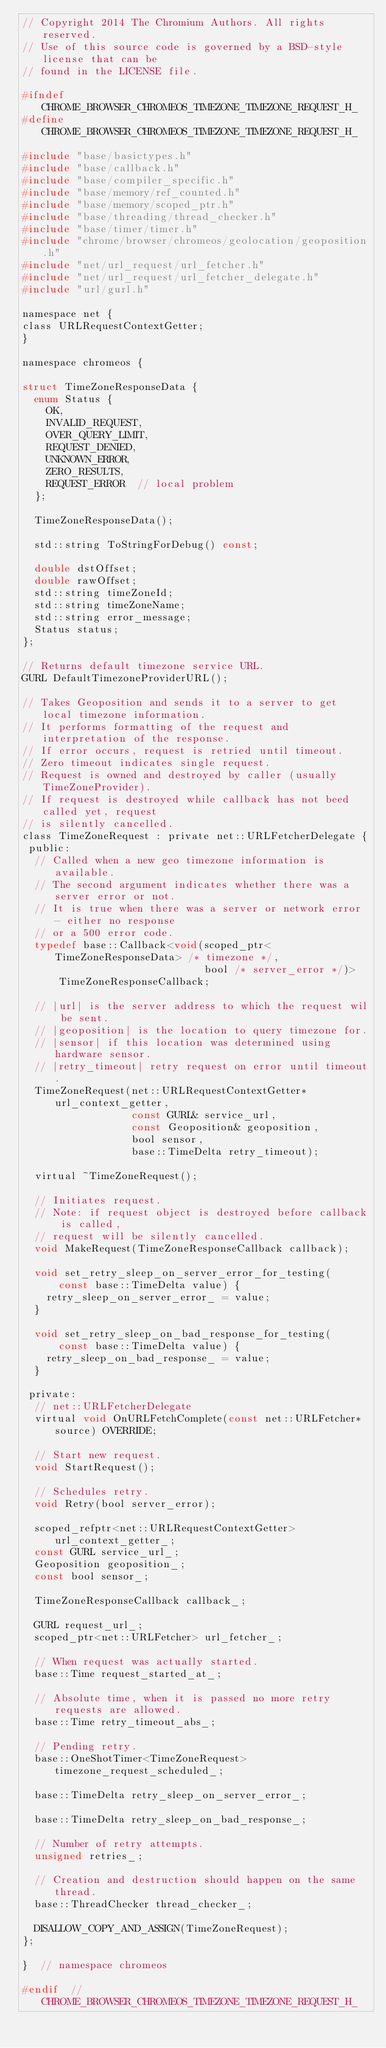<code> <loc_0><loc_0><loc_500><loc_500><_C_>// Copyright 2014 The Chromium Authors. All rights reserved.
// Use of this source code is governed by a BSD-style license that can be
// found in the LICENSE file.

#ifndef CHROME_BROWSER_CHROMEOS_TIMEZONE_TIMEZONE_REQUEST_H_
#define CHROME_BROWSER_CHROMEOS_TIMEZONE_TIMEZONE_REQUEST_H_

#include "base/basictypes.h"
#include "base/callback.h"
#include "base/compiler_specific.h"
#include "base/memory/ref_counted.h"
#include "base/memory/scoped_ptr.h"
#include "base/threading/thread_checker.h"
#include "base/timer/timer.h"
#include "chrome/browser/chromeos/geolocation/geoposition.h"
#include "net/url_request/url_fetcher.h"
#include "net/url_request/url_fetcher_delegate.h"
#include "url/gurl.h"

namespace net {
class URLRequestContextGetter;
}

namespace chromeos {

struct TimeZoneResponseData {
  enum Status {
    OK,
    INVALID_REQUEST,
    OVER_QUERY_LIMIT,
    REQUEST_DENIED,
    UNKNOWN_ERROR,
    ZERO_RESULTS,
    REQUEST_ERROR  // local problem
  };

  TimeZoneResponseData();

  std::string ToStringForDebug() const;

  double dstOffset;
  double rawOffset;
  std::string timeZoneId;
  std::string timeZoneName;
  std::string error_message;
  Status status;
};

// Returns default timezone service URL.
GURL DefaultTimezoneProviderURL();

// Takes Geoposition and sends it to a server to get local timezone information.
// It performs formatting of the request and interpretation of the response.
// If error occurs, request is retried until timeout.
// Zero timeout indicates single request.
// Request is owned and destroyed by caller (usually TimeZoneProvider).
// If request is destroyed while callback has not beed called yet, request
// is silently cancelled.
class TimeZoneRequest : private net::URLFetcherDelegate {
 public:
  // Called when a new geo timezone information is available.
  // The second argument indicates whether there was a server error or not.
  // It is true when there was a server or network error - either no response
  // or a 500 error code.
  typedef base::Callback<void(scoped_ptr<TimeZoneResponseData> /* timezone */,
                              bool /* server_error */)>
      TimeZoneResponseCallback;

  // |url| is the server address to which the request wil be sent.
  // |geoposition| is the location to query timezone for.
  // |sensor| if this location was determined using hardware sensor.
  // |retry_timeout| retry request on error until timeout.
  TimeZoneRequest(net::URLRequestContextGetter* url_context_getter,
                  const GURL& service_url,
                  const Geoposition& geoposition,
                  bool sensor,
                  base::TimeDelta retry_timeout);

  virtual ~TimeZoneRequest();

  // Initiates request.
  // Note: if request object is destroyed before callback is called,
  // request will be silently cancelled.
  void MakeRequest(TimeZoneResponseCallback callback);

  void set_retry_sleep_on_server_error_for_testing(
      const base::TimeDelta value) {
    retry_sleep_on_server_error_ = value;
  }

  void set_retry_sleep_on_bad_response_for_testing(
      const base::TimeDelta value) {
    retry_sleep_on_bad_response_ = value;
  }

 private:
  // net::URLFetcherDelegate
  virtual void OnURLFetchComplete(const net::URLFetcher* source) OVERRIDE;

  // Start new request.
  void StartRequest();

  // Schedules retry.
  void Retry(bool server_error);

  scoped_refptr<net::URLRequestContextGetter> url_context_getter_;
  const GURL service_url_;
  Geoposition geoposition_;
  const bool sensor_;

  TimeZoneResponseCallback callback_;

  GURL request_url_;
  scoped_ptr<net::URLFetcher> url_fetcher_;

  // When request was actually started.
  base::Time request_started_at_;

  // Absolute time, when it is passed no more retry requests are allowed.
  base::Time retry_timeout_abs_;

  // Pending retry.
  base::OneShotTimer<TimeZoneRequest> timezone_request_scheduled_;

  base::TimeDelta retry_sleep_on_server_error_;

  base::TimeDelta retry_sleep_on_bad_response_;

  // Number of retry attempts.
  unsigned retries_;

  // Creation and destruction should happen on the same thread.
  base::ThreadChecker thread_checker_;

  DISALLOW_COPY_AND_ASSIGN(TimeZoneRequest);
};

}  // namespace chromeos

#endif  // CHROME_BROWSER_CHROMEOS_TIMEZONE_TIMEZONE_REQUEST_H_
</code> 